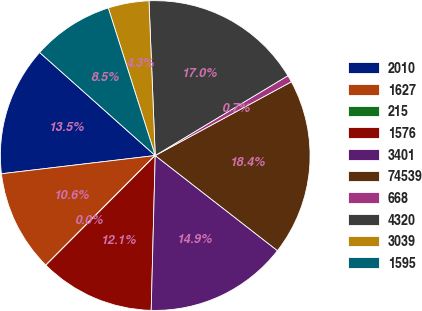<chart> <loc_0><loc_0><loc_500><loc_500><pie_chart><fcel>2010<fcel>1627<fcel>215<fcel>1576<fcel>3401<fcel>74539<fcel>668<fcel>4320<fcel>3039<fcel>1595<nl><fcel>13.47%<fcel>10.64%<fcel>0.01%<fcel>12.06%<fcel>14.89%<fcel>18.43%<fcel>0.72%<fcel>17.02%<fcel>4.26%<fcel>8.51%<nl></chart> 